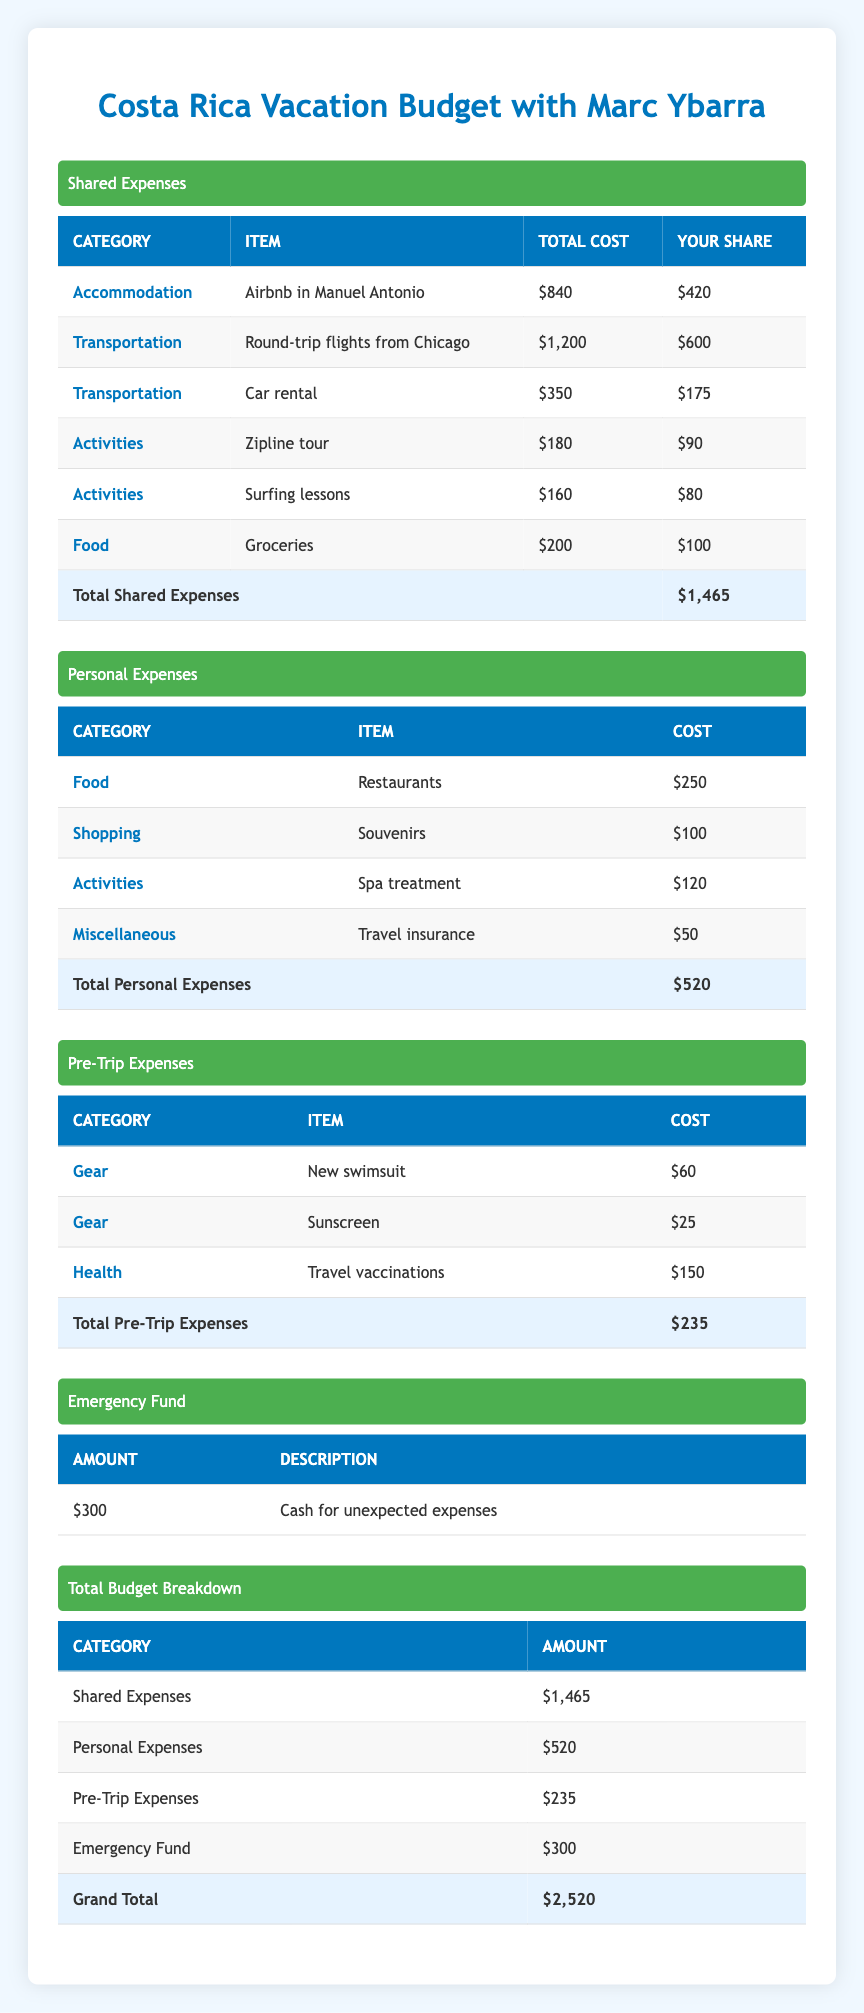What is the total cost for shared transportation expenses? The shared transportation expenses consist of the round-trip flights ($1,200) and the car rental ($350). To find the total, we add these two amounts: $1,200 + $350 = $1,550.
Answer: 1550 How much are your personal expenses for food? According to the table, your personal expenses for food include $250 for restaurants.
Answer: 250 Did the total shared expenses exceed your personal expenses? The total shared expenses are $1,465, and the total personal expenses are $520. Since $1,465 is greater than $520, the statement is true.
Answer: Yes What is the total amount you need for the emergency fund? The emergency fund amount is specified as $300 for unexpected expenses. There are no additional calculations needed.
Answer: 300 If you take out the emergency fund from the grand total, what is the remaining budget? The grand total is $2,520, and if we subtract the emergency fund of $300, we have: $2,520 - $300 = $2,220 remaining budget.
Answer: 2220 What category has the highest shared expense? Looking at the shared expenses, we have accommodation at $840, transportation (flights) at $1,200, transportation (car rental) at $350, activities (zipline) at $180, activities (surfing) at $160, and food (groceries) at $200. The highest is $1,200 for transportation (round-trip flights).
Answer: Transportation How much did you spend on pre-trip gear in total? The pre-trip expenses for gear consist of a new swimsuit at $60 and sunscreen at $25. Adding these gives us $60 + $25 = $85 for total pre-trip gear expenses.
Answer: 85 Was your share of the food category expenses lower than your personal restaurant expenses? Your share of food expenses for groceries is $100, and your personal expenses for restaurants are $250. Since $100 is less than $250, the statement is true.
Answer: Yes What is the sum of all personal expenses? The personal expenses table includes restaurants ($250), souvenirs ($100), spa treatment ($120), and travel insurance ($50). Adding these amounts gives: $250 + $100 + $120 + $50 = $520.
Answer: 520 